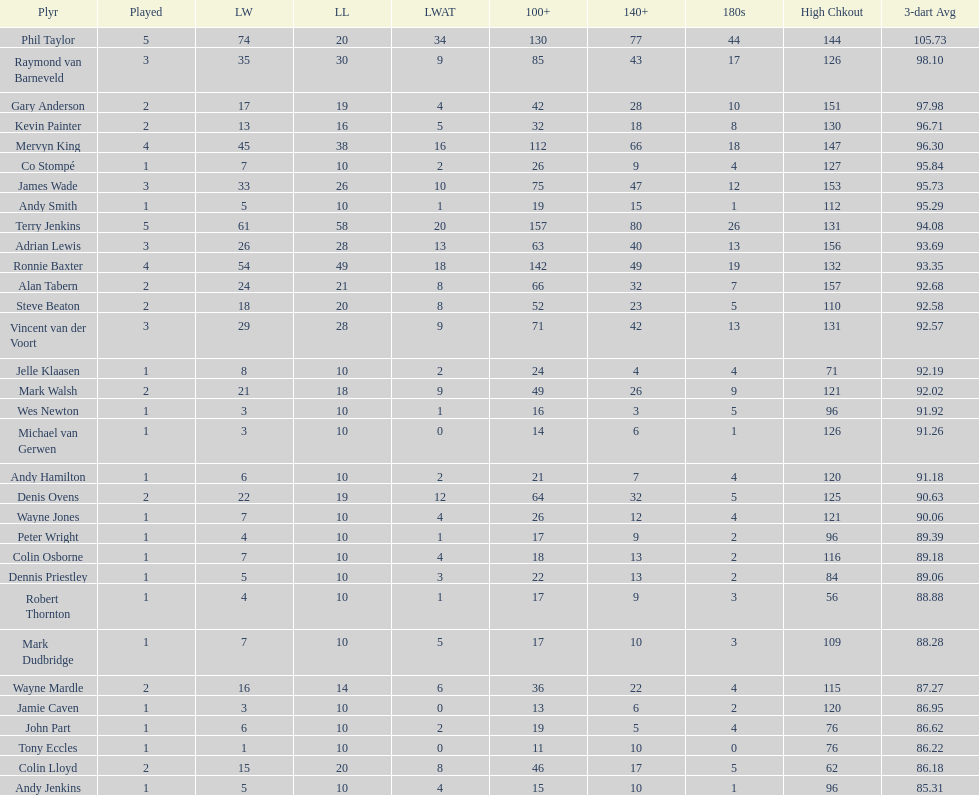List each of the players with a high checkout of 131. Terry Jenkins, Vincent van der Voort. 